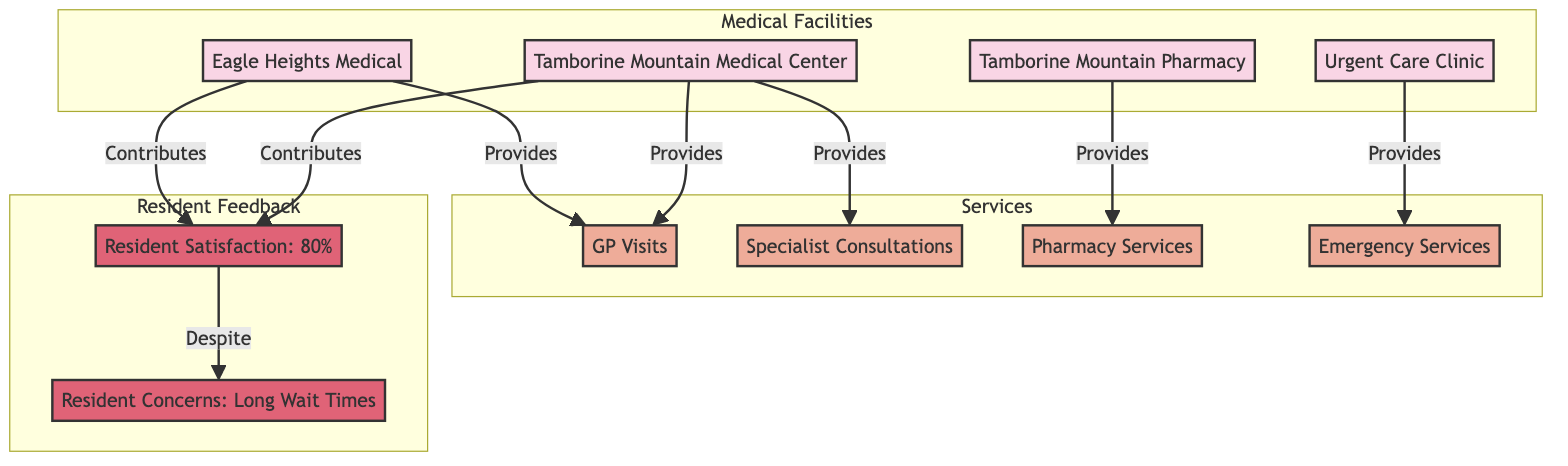What are the four medical facilities in Tamborine Mountain? The diagram presents four nodes representing medical facilities: Tamborine Mountain Medical Center, Eagle Heights Medical, Tamborine Mountain Pharmacy, and Urgent Care Clinic.
Answer: Tamborine Mountain Medical Center, Eagle Heights Medical, Tamborine Mountain Pharmacy, Urgent Care Clinic How many types of services are provided? The diagram shows four types of services offered: GP Visits, Specialist Consultations, Pharmacy Services, and Emergency Services. Thus, there are four distinct service types.
Answer: 4 What is the resident satisfaction rate according to the diagram? In the Resident Feedback section, the node clearly indicates that the resident satisfaction rate is 80%. Therefore, it directly answers the question.
Answer: 80% Which medical facilities provide GP Visits? The diagram indicates that both the Tamborine Mountain Medical Center and Eagle Heights Medical facility provide GP Visits. This answer is derived from the arrows indicating service provision.
Answer: Tamborine Mountain Medical Center, Eagle Heights Medical What is the primary resident concern highlighted in the diagram? The Resident Feedback section includes a node labeled "Resident Concerns" that states "Long Wait Times." This is the most notable concern indicated in the diagram.
Answer: Long Wait Times Which two medical facilities contribute to resident satisfaction? The diagram shows arrows pointing from both Tamborine Mountain Medical Center and Eagle Heights Medical towards the resident satisfaction node, illustrating that both facilities contribute positively to resident satisfaction.
Answer: Tamborine Mountain Medical Center, Eagle Heights Medical What service does the Urgent Care Clinic provide? The diagram specifies that the Urgent Care Clinic is associated with providing Emergency Services, as indicated by the relationship shown with an arrow connecting them.
Answer: Emergency Services What does the resident satisfaction rate denote in relation to resident concerns? The diagram presents an indication that despite achieving an 80% satisfaction rate, residents still have concerns about long wait times, showcasing a disparity between satisfaction and specific grievances.
Answer: Despite How many facilities are connected to pharmacy services? According to the diagram, pharmacy services are provided exclusively by Tamborine Mountain Pharmacy, so there is one facility linked to this service.
Answer: 1 